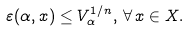<formula> <loc_0><loc_0><loc_500><loc_500>\varepsilon ( \alpha , x ) \leq V _ { \alpha } ^ { 1 / n } , \, \forall \, x \in X .</formula> 